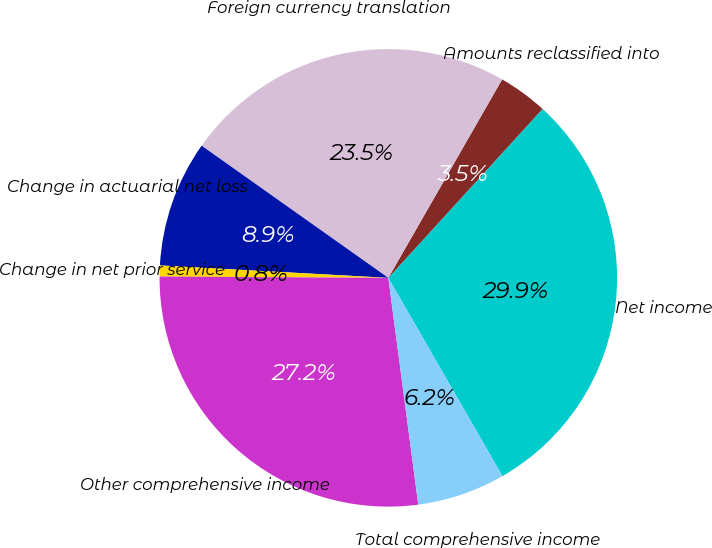Convert chart. <chart><loc_0><loc_0><loc_500><loc_500><pie_chart><fcel>Net income<fcel>Amounts reclassified into<fcel>Foreign currency translation<fcel>Change in actuarial net loss<fcel>Change in net prior service<fcel>Other comprehensive income<fcel>Total comprehensive income<nl><fcel>29.91%<fcel>3.49%<fcel>23.48%<fcel>8.94%<fcel>0.77%<fcel>27.18%<fcel>6.22%<nl></chart> 